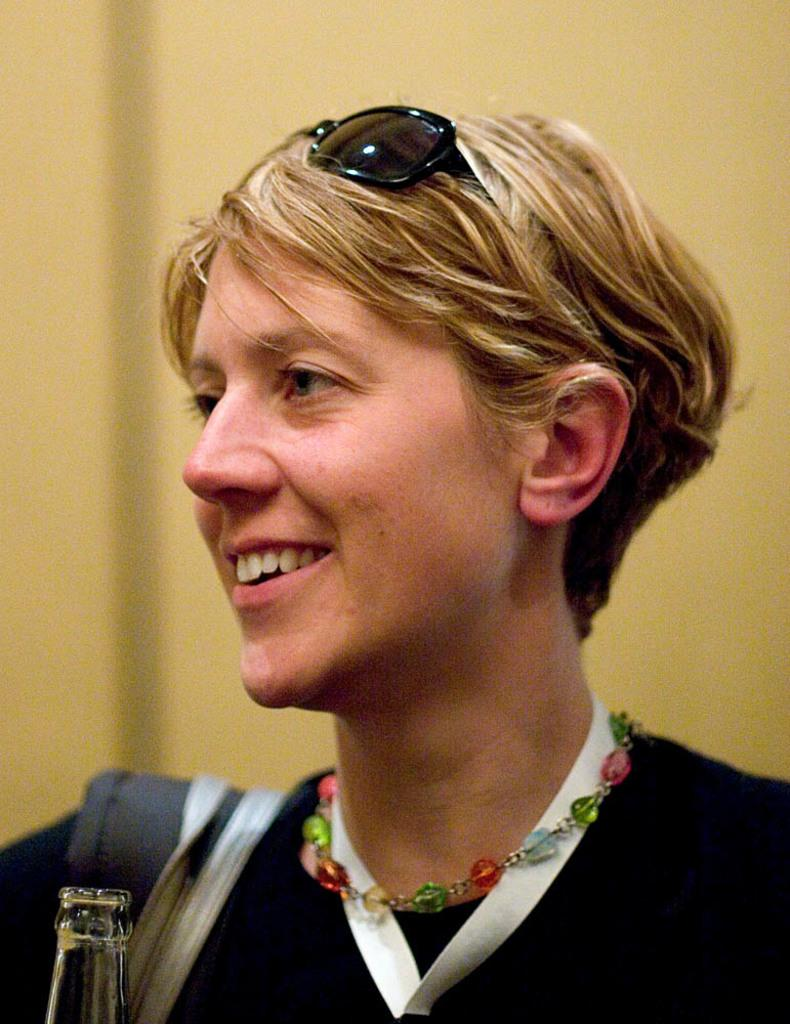Who is present in the image? There is a woman in the image. What is the woman's facial expression? The woman is smiling. What accessories does the woman have on her head? The woman has goggles on her head. What type of jewelry is the woman wearing? The woman is wearing a chain. What can be seen in the background of the image? There is a wall in the background of the image. What type of ornament is hanging from the woman's neck in the image? There is no ornament hanging from the woman's neck in the image; she is wearing a chain. How many people are present in the image? There is only one person present in the image, which is the woman. 